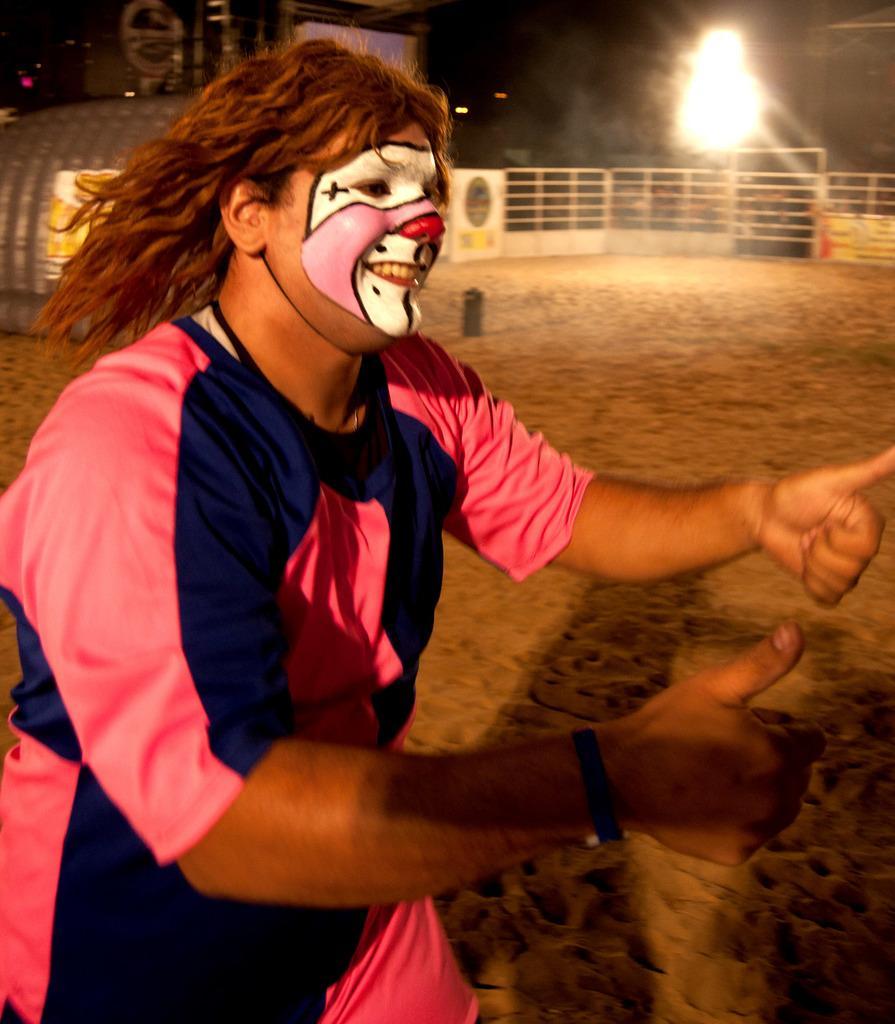Please provide a concise description of this image. This image is taken outdoors. On the left side of the image a person is walking on the ground. He is with a painting on his face and he is with a smiling face. At the bottom of the image there is a ground. In the background there is a railing. There is a light and is a board with a text on it. There is an object. 